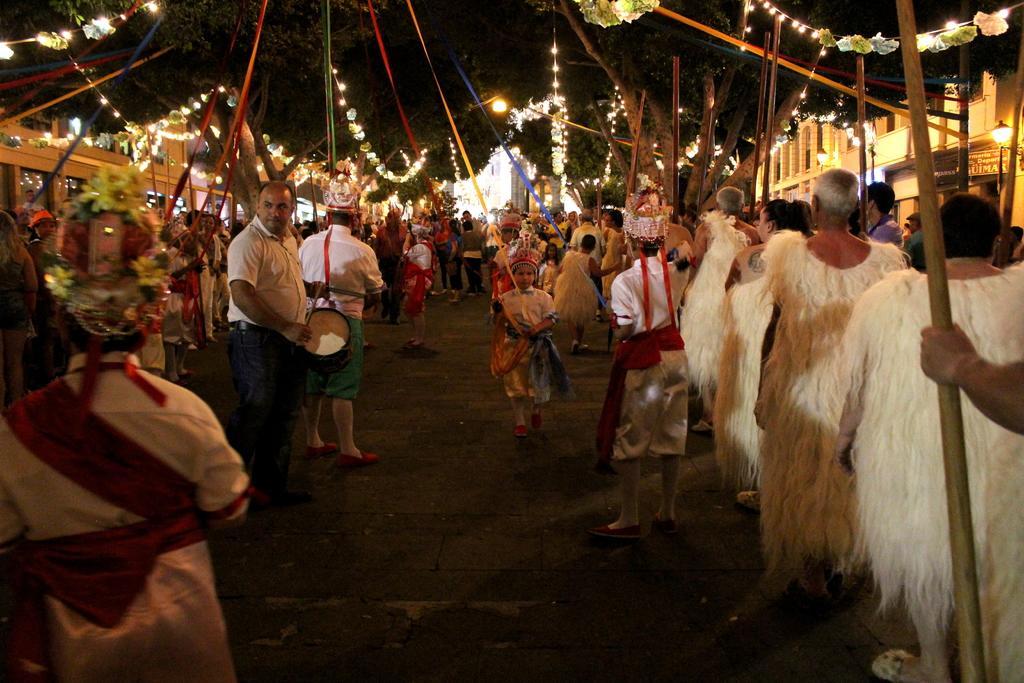In one or two sentences, can you explain what this image depicts? In this picture I can see there is a parade and there are few people standing on to right and they are wearing white dresses and it has feathers on it. There are few others wearing uniforms and there are trees, buildings on both the sides and there are lights attached to the ceiling. 